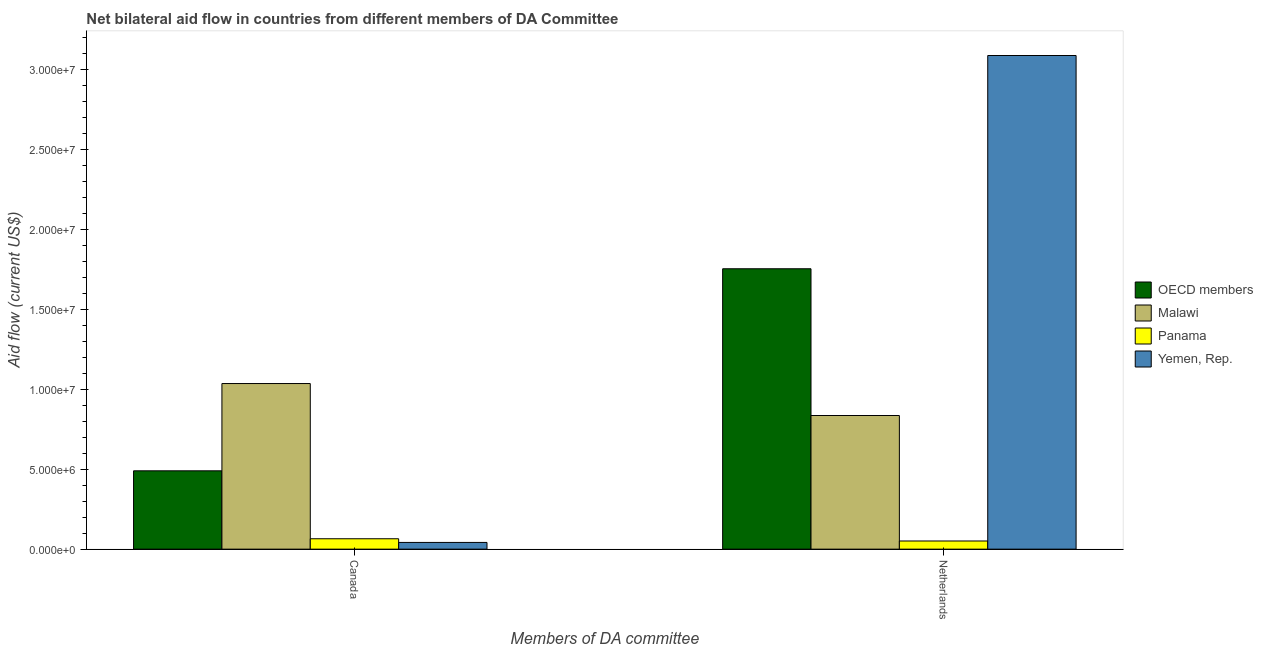How many groups of bars are there?
Provide a succinct answer. 2. How many bars are there on the 1st tick from the left?
Your response must be concise. 4. What is the label of the 2nd group of bars from the left?
Keep it short and to the point. Netherlands. What is the amount of aid given by netherlands in OECD members?
Your response must be concise. 1.75e+07. Across all countries, what is the maximum amount of aid given by canada?
Offer a terse response. 1.04e+07. Across all countries, what is the minimum amount of aid given by canada?
Ensure brevity in your answer.  4.20e+05. In which country was the amount of aid given by canada maximum?
Provide a short and direct response. Malawi. In which country was the amount of aid given by netherlands minimum?
Provide a short and direct response. Panama. What is the total amount of aid given by canada in the graph?
Make the answer very short. 1.63e+07. What is the difference between the amount of aid given by canada in Malawi and that in OECD members?
Offer a very short reply. 5.46e+06. What is the difference between the amount of aid given by canada in Panama and the amount of aid given by netherlands in OECD members?
Provide a short and direct response. -1.69e+07. What is the average amount of aid given by canada per country?
Offer a very short reply. 4.08e+06. What is the difference between the amount of aid given by canada and amount of aid given by netherlands in OECD members?
Give a very brief answer. -1.26e+07. In how many countries, is the amount of aid given by netherlands greater than 24000000 US$?
Ensure brevity in your answer.  1. What is the ratio of the amount of aid given by canada in OECD members to that in Panama?
Offer a terse response. 7.54. Is the amount of aid given by canada in Panama less than that in Yemen, Rep.?
Give a very brief answer. No. In how many countries, is the amount of aid given by netherlands greater than the average amount of aid given by netherlands taken over all countries?
Make the answer very short. 2. What does the 4th bar from the left in Netherlands represents?
Your answer should be compact. Yemen, Rep. What does the 3rd bar from the right in Canada represents?
Your answer should be very brief. Malawi. How many bars are there?
Your answer should be compact. 8. Are the values on the major ticks of Y-axis written in scientific E-notation?
Provide a short and direct response. Yes. Does the graph contain grids?
Offer a very short reply. No. Where does the legend appear in the graph?
Your answer should be very brief. Center right. How many legend labels are there?
Ensure brevity in your answer.  4. How are the legend labels stacked?
Make the answer very short. Vertical. What is the title of the graph?
Offer a very short reply. Net bilateral aid flow in countries from different members of DA Committee. What is the label or title of the X-axis?
Your answer should be very brief. Members of DA committee. What is the Aid flow (current US$) in OECD members in Canada?
Your response must be concise. 4.90e+06. What is the Aid flow (current US$) of Malawi in Canada?
Your answer should be very brief. 1.04e+07. What is the Aid flow (current US$) of Panama in Canada?
Keep it short and to the point. 6.50e+05. What is the Aid flow (current US$) of Yemen, Rep. in Canada?
Offer a terse response. 4.20e+05. What is the Aid flow (current US$) in OECD members in Netherlands?
Provide a succinct answer. 1.75e+07. What is the Aid flow (current US$) of Malawi in Netherlands?
Provide a succinct answer. 8.36e+06. What is the Aid flow (current US$) of Panama in Netherlands?
Offer a very short reply. 5.10e+05. What is the Aid flow (current US$) in Yemen, Rep. in Netherlands?
Provide a short and direct response. 3.09e+07. Across all Members of DA committee, what is the maximum Aid flow (current US$) of OECD members?
Your answer should be very brief. 1.75e+07. Across all Members of DA committee, what is the maximum Aid flow (current US$) in Malawi?
Keep it short and to the point. 1.04e+07. Across all Members of DA committee, what is the maximum Aid flow (current US$) of Panama?
Make the answer very short. 6.50e+05. Across all Members of DA committee, what is the maximum Aid flow (current US$) in Yemen, Rep.?
Make the answer very short. 3.09e+07. Across all Members of DA committee, what is the minimum Aid flow (current US$) in OECD members?
Your answer should be very brief. 4.90e+06. Across all Members of DA committee, what is the minimum Aid flow (current US$) in Malawi?
Your answer should be compact. 8.36e+06. Across all Members of DA committee, what is the minimum Aid flow (current US$) in Panama?
Offer a terse response. 5.10e+05. What is the total Aid flow (current US$) in OECD members in the graph?
Your answer should be very brief. 2.24e+07. What is the total Aid flow (current US$) in Malawi in the graph?
Provide a succinct answer. 1.87e+07. What is the total Aid flow (current US$) of Panama in the graph?
Ensure brevity in your answer.  1.16e+06. What is the total Aid flow (current US$) of Yemen, Rep. in the graph?
Provide a short and direct response. 3.13e+07. What is the difference between the Aid flow (current US$) of OECD members in Canada and that in Netherlands?
Your answer should be very brief. -1.26e+07. What is the difference between the Aid flow (current US$) in Malawi in Canada and that in Netherlands?
Keep it short and to the point. 2.00e+06. What is the difference between the Aid flow (current US$) in Yemen, Rep. in Canada and that in Netherlands?
Provide a short and direct response. -3.05e+07. What is the difference between the Aid flow (current US$) of OECD members in Canada and the Aid flow (current US$) of Malawi in Netherlands?
Offer a very short reply. -3.46e+06. What is the difference between the Aid flow (current US$) of OECD members in Canada and the Aid flow (current US$) of Panama in Netherlands?
Offer a terse response. 4.39e+06. What is the difference between the Aid flow (current US$) in OECD members in Canada and the Aid flow (current US$) in Yemen, Rep. in Netherlands?
Make the answer very short. -2.60e+07. What is the difference between the Aid flow (current US$) of Malawi in Canada and the Aid flow (current US$) of Panama in Netherlands?
Keep it short and to the point. 9.85e+06. What is the difference between the Aid flow (current US$) in Malawi in Canada and the Aid flow (current US$) in Yemen, Rep. in Netherlands?
Keep it short and to the point. -2.05e+07. What is the difference between the Aid flow (current US$) of Panama in Canada and the Aid flow (current US$) of Yemen, Rep. in Netherlands?
Your answer should be very brief. -3.02e+07. What is the average Aid flow (current US$) of OECD members per Members of DA committee?
Your answer should be very brief. 1.12e+07. What is the average Aid flow (current US$) of Malawi per Members of DA committee?
Provide a short and direct response. 9.36e+06. What is the average Aid flow (current US$) in Panama per Members of DA committee?
Give a very brief answer. 5.80e+05. What is the average Aid flow (current US$) in Yemen, Rep. per Members of DA committee?
Your answer should be compact. 1.56e+07. What is the difference between the Aid flow (current US$) of OECD members and Aid flow (current US$) of Malawi in Canada?
Provide a succinct answer. -5.46e+06. What is the difference between the Aid flow (current US$) of OECD members and Aid flow (current US$) of Panama in Canada?
Make the answer very short. 4.25e+06. What is the difference between the Aid flow (current US$) of OECD members and Aid flow (current US$) of Yemen, Rep. in Canada?
Your response must be concise. 4.48e+06. What is the difference between the Aid flow (current US$) in Malawi and Aid flow (current US$) in Panama in Canada?
Provide a succinct answer. 9.71e+06. What is the difference between the Aid flow (current US$) in Malawi and Aid flow (current US$) in Yemen, Rep. in Canada?
Offer a very short reply. 9.94e+06. What is the difference between the Aid flow (current US$) in OECD members and Aid flow (current US$) in Malawi in Netherlands?
Offer a very short reply. 9.18e+06. What is the difference between the Aid flow (current US$) in OECD members and Aid flow (current US$) in Panama in Netherlands?
Your answer should be compact. 1.70e+07. What is the difference between the Aid flow (current US$) of OECD members and Aid flow (current US$) of Yemen, Rep. in Netherlands?
Offer a very short reply. -1.33e+07. What is the difference between the Aid flow (current US$) in Malawi and Aid flow (current US$) in Panama in Netherlands?
Keep it short and to the point. 7.85e+06. What is the difference between the Aid flow (current US$) in Malawi and Aid flow (current US$) in Yemen, Rep. in Netherlands?
Ensure brevity in your answer.  -2.25e+07. What is the difference between the Aid flow (current US$) in Panama and Aid flow (current US$) in Yemen, Rep. in Netherlands?
Your answer should be compact. -3.04e+07. What is the ratio of the Aid flow (current US$) of OECD members in Canada to that in Netherlands?
Offer a very short reply. 0.28. What is the ratio of the Aid flow (current US$) of Malawi in Canada to that in Netherlands?
Ensure brevity in your answer.  1.24. What is the ratio of the Aid flow (current US$) of Panama in Canada to that in Netherlands?
Provide a succinct answer. 1.27. What is the ratio of the Aid flow (current US$) of Yemen, Rep. in Canada to that in Netherlands?
Offer a terse response. 0.01. What is the difference between the highest and the second highest Aid flow (current US$) of OECD members?
Give a very brief answer. 1.26e+07. What is the difference between the highest and the second highest Aid flow (current US$) of Yemen, Rep.?
Your response must be concise. 3.05e+07. What is the difference between the highest and the lowest Aid flow (current US$) in OECD members?
Make the answer very short. 1.26e+07. What is the difference between the highest and the lowest Aid flow (current US$) of Malawi?
Provide a short and direct response. 2.00e+06. What is the difference between the highest and the lowest Aid flow (current US$) of Panama?
Keep it short and to the point. 1.40e+05. What is the difference between the highest and the lowest Aid flow (current US$) of Yemen, Rep.?
Ensure brevity in your answer.  3.05e+07. 